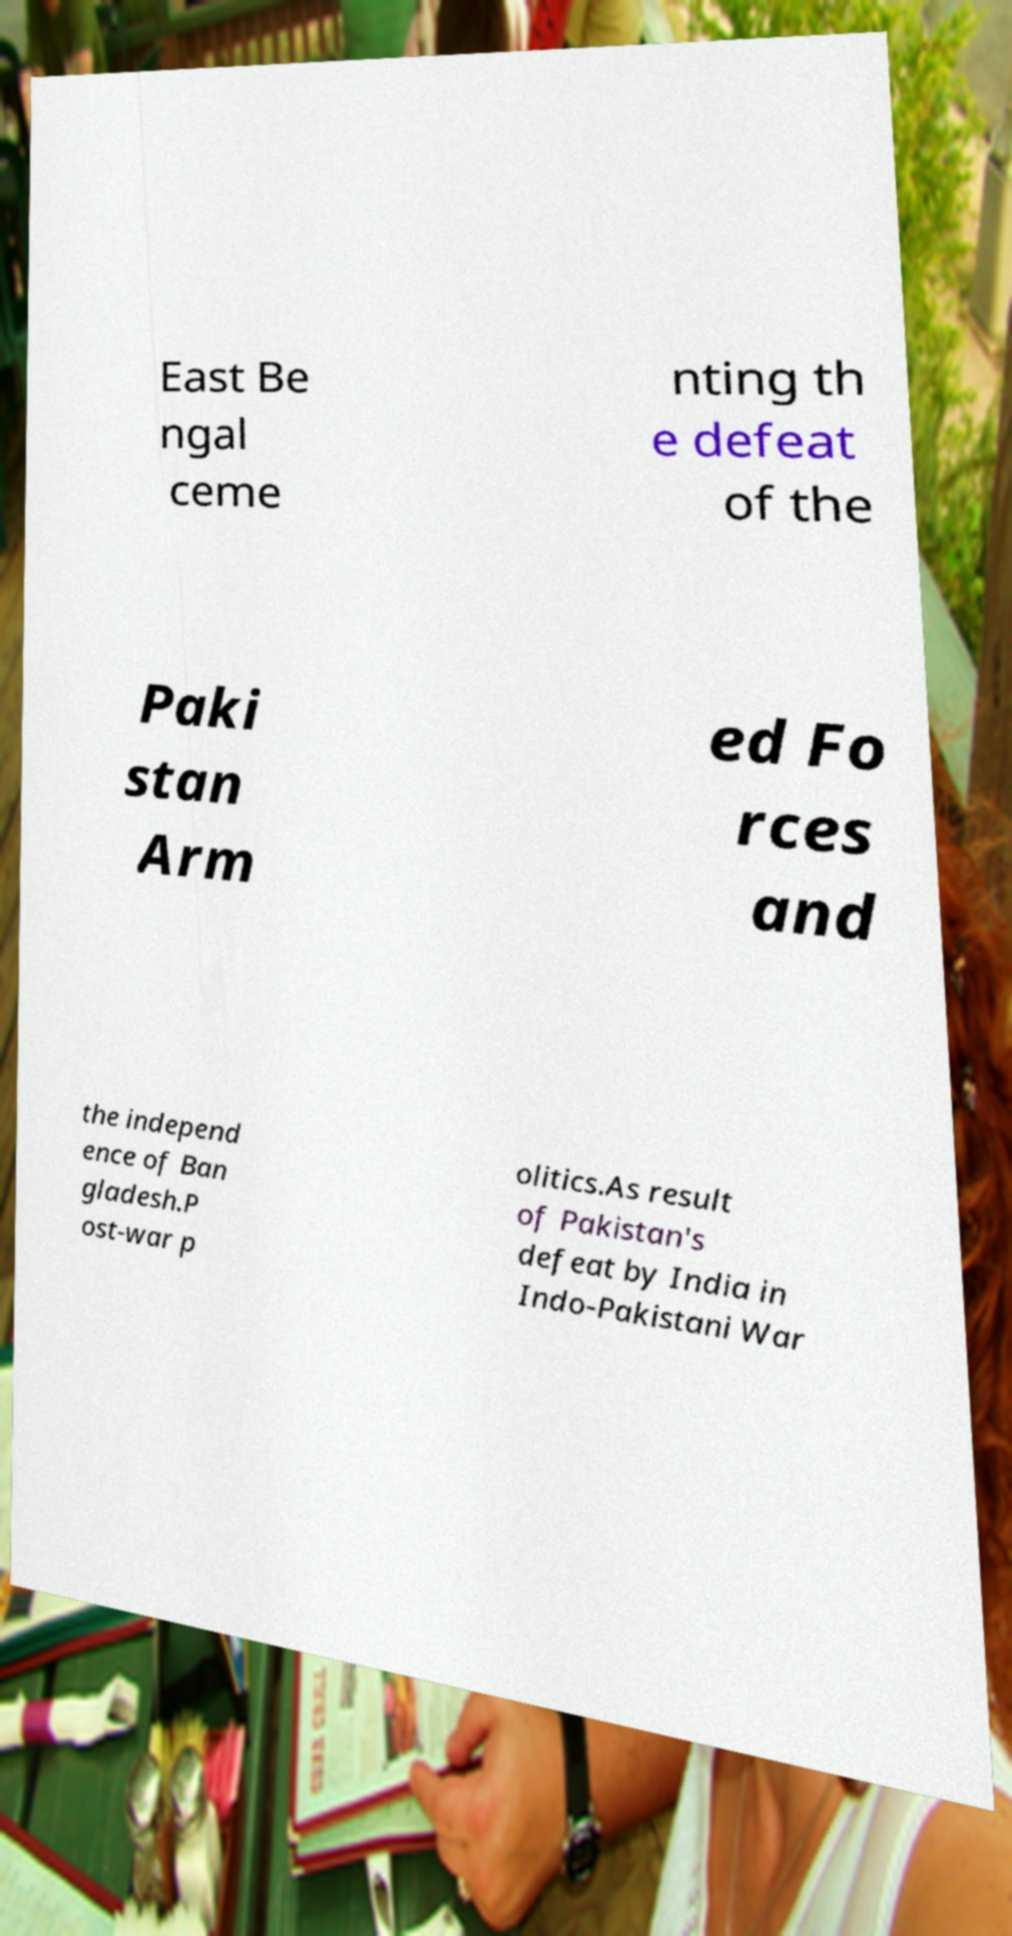I need the written content from this picture converted into text. Can you do that? East Be ngal ceme nting th e defeat of the Paki stan Arm ed Fo rces and the independ ence of Ban gladesh.P ost-war p olitics.As result of Pakistan's defeat by India in Indo-Pakistani War 